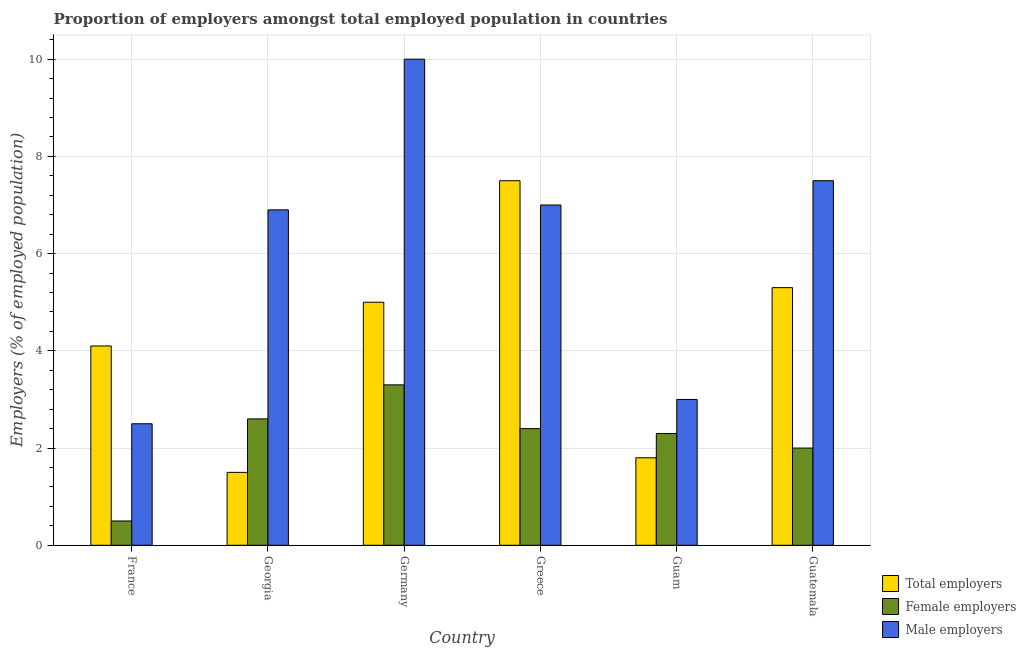How many groups of bars are there?
Provide a succinct answer. 6. How many bars are there on the 3rd tick from the left?
Offer a terse response. 3. How many bars are there on the 5th tick from the right?
Offer a terse response. 3. What is the label of the 6th group of bars from the left?
Your response must be concise. Guatemala. In how many cases, is the number of bars for a given country not equal to the number of legend labels?
Offer a very short reply. 0. Across all countries, what is the maximum percentage of total employers?
Offer a terse response. 7.5. In which country was the percentage of total employers maximum?
Keep it short and to the point. Greece. What is the total percentage of female employers in the graph?
Give a very brief answer. 13.1. What is the difference between the percentage of female employers in Guam and that in Guatemala?
Offer a terse response. 0.3. What is the difference between the percentage of male employers in Germany and the percentage of female employers in Greece?
Make the answer very short. 7.6. What is the average percentage of male employers per country?
Keep it short and to the point. 6.15. What is the difference between the percentage of male employers and percentage of total employers in France?
Ensure brevity in your answer.  -1.6. In how many countries, is the percentage of female employers greater than 2.4 %?
Ensure brevity in your answer.  3. What is the ratio of the percentage of total employers in Greece to that in Guam?
Your answer should be compact. 4.17. Is the difference between the percentage of total employers in Georgia and Greece greater than the difference between the percentage of female employers in Georgia and Greece?
Give a very brief answer. No. What is the difference between the highest and the second highest percentage of male employers?
Offer a very short reply. 2.5. What is the difference between the highest and the lowest percentage of female employers?
Make the answer very short. 2.8. What does the 1st bar from the left in France represents?
Your response must be concise. Total employers. What does the 3rd bar from the right in Georgia represents?
Provide a succinct answer. Total employers. Is it the case that in every country, the sum of the percentage of total employers and percentage of female employers is greater than the percentage of male employers?
Your answer should be compact. No. How many bars are there?
Provide a short and direct response. 18. Are all the bars in the graph horizontal?
Offer a very short reply. No. Are the values on the major ticks of Y-axis written in scientific E-notation?
Provide a succinct answer. No. Does the graph contain grids?
Offer a very short reply. Yes. Where does the legend appear in the graph?
Offer a terse response. Bottom right. How many legend labels are there?
Offer a terse response. 3. What is the title of the graph?
Offer a terse response. Proportion of employers amongst total employed population in countries. What is the label or title of the X-axis?
Your answer should be compact. Country. What is the label or title of the Y-axis?
Ensure brevity in your answer.  Employers (% of employed population). What is the Employers (% of employed population) of Total employers in France?
Offer a terse response. 4.1. What is the Employers (% of employed population) of Female employers in Georgia?
Your answer should be compact. 2.6. What is the Employers (% of employed population) of Male employers in Georgia?
Provide a short and direct response. 6.9. What is the Employers (% of employed population) in Total employers in Germany?
Provide a short and direct response. 5. What is the Employers (% of employed population) in Female employers in Germany?
Ensure brevity in your answer.  3.3. What is the Employers (% of employed population) in Female employers in Greece?
Your response must be concise. 2.4. What is the Employers (% of employed population) in Total employers in Guam?
Ensure brevity in your answer.  1.8. What is the Employers (% of employed population) of Female employers in Guam?
Ensure brevity in your answer.  2.3. What is the Employers (% of employed population) in Male employers in Guam?
Your answer should be very brief. 3. What is the Employers (% of employed population) in Total employers in Guatemala?
Ensure brevity in your answer.  5.3. What is the Employers (% of employed population) of Female employers in Guatemala?
Your response must be concise. 2. Across all countries, what is the maximum Employers (% of employed population) of Total employers?
Your answer should be compact. 7.5. Across all countries, what is the maximum Employers (% of employed population) in Female employers?
Give a very brief answer. 3.3. Across all countries, what is the minimum Employers (% of employed population) of Total employers?
Offer a very short reply. 1.5. Across all countries, what is the minimum Employers (% of employed population) in Male employers?
Offer a terse response. 2.5. What is the total Employers (% of employed population) in Total employers in the graph?
Ensure brevity in your answer.  25.2. What is the total Employers (% of employed population) of Female employers in the graph?
Your answer should be compact. 13.1. What is the total Employers (% of employed population) of Male employers in the graph?
Provide a succinct answer. 36.9. What is the difference between the Employers (% of employed population) in Total employers in France and that in Georgia?
Keep it short and to the point. 2.6. What is the difference between the Employers (% of employed population) of Female employers in France and that in Georgia?
Offer a terse response. -2.1. What is the difference between the Employers (% of employed population) of Male employers in France and that in Germany?
Provide a succinct answer. -7.5. What is the difference between the Employers (% of employed population) of Total employers in France and that in Greece?
Your answer should be compact. -3.4. What is the difference between the Employers (% of employed population) of Male employers in France and that in Greece?
Give a very brief answer. -4.5. What is the difference between the Employers (% of employed population) in Female employers in France and that in Guam?
Your response must be concise. -1.8. What is the difference between the Employers (% of employed population) in Male employers in France and that in Guatemala?
Provide a short and direct response. -5. What is the difference between the Employers (% of employed population) in Total employers in Georgia and that in Guam?
Provide a succinct answer. -0.3. What is the difference between the Employers (% of employed population) of Female employers in Georgia and that in Guam?
Ensure brevity in your answer.  0.3. What is the difference between the Employers (% of employed population) of Male employers in Georgia and that in Guam?
Offer a very short reply. 3.9. What is the difference between the Employers (% of employed population) of Total employers in Georgia and that in Guatemala?
Offer a terse response. -3.8. What is the difference between the Employers (% of employed population) in Female employers in Georgia and that in Guatemala?
Provide a succinct answer. 0.6. What is the difference between the Employers (% of employed population) in Total employers in Germany and that in Greece?
Ensure brevity in your answer.  -2.5. What is the difference between the Employers (% of employed population) of Female employers in Germany and that in Greece?
Offer a very short reply. 0.9. What is the difference between the Employers (% of employed population) in Male employers in Germany and that in Greece?
Give a very brief answer. 3. What is the difference between the Employers (% of employed population) in Total employers in Germany and that in Guam?
Ensure brevity in your answer.  3.2. What is the difference between the Employers (% of employed population) of Male employers in Germany and that in Guam?
Provide a succinct answer. 7. What is the difference between the Employers (% of employed population) in Total employers in Germany and that in Guatemala?
Provide a succinct answer. -0.3. What is the difference between the Employers (% of employed population) in Female employers in Germany and that in Guatemala?
Keep it short and to the point. 1.3. What is the difference between the Employers (% of employed population) of Male employers in Germany and that in Guatemala?
Provide a short and direct response. 2.5. What is the difference between the Employers (% of employed population) in Total employers in Greece and that in Guam?
Your response must be concise. 5.7. What is the difference between the Employers (% of employed population) of Total employers in Greece and that in Guatemala?
Ensure brevity in your answer.  2.2. What is the difference between the Employers (% of employed population) in Female employers in Greece and that in Guatemala?
Offer a very short reply. 0.4. What is the difference between the Employers (% of employed population) of Total employers in Guam and that in Guatemala?
Keep it short and to the point. -3.5. What is the difference between the Employers (% of employed population) in Total employers in France and the Employers (% of employed population) in Female employers in Georgia?
Ensure brevity in your answer.  1.5. What is the difference between the Employers (% of employed population) of Total employers in France and the Employers (% of employed population) of Male employers in Georgia?
Give a very brief answer. -2.8. What is the difference between the Employers (% of employed population) of Female employers in France and the Employers (% of employed population) of Male employers in Georgia?
Provide a succinct answer. -6.4. What is the difference between the Employers (% of employed population) in Total employers in France and the Employers (% of employed population) in Female employers in Germany?
Keep it short and to the point. 0.8. What is the difference between the Employers (% of employed population) of Total employers in France and the Employers (% of employed population) of Male employers in Germany?
Your answer should be compact. -5.9. What is the difference between the Employers (% of employed population) of Total employers in France and the Employers (% of employed population) of Female employers in Greece?
Your response must be concise. 1.7. What is the difference between the Employers (% of employed population) of Total employers in France and the Employers (% of employed population) of Male employers in Greece?
Offer a terse response. -2.9. What is the difference between the Employers (% of employed population) of Total employers in France and the Employers (% of employed population) of Female employers in Guam?
Keep it short and to the point. 1.8. What is the difference between the Employers (% of employed population) in Total employers in France and the Employers (% of employed population) in Female employers in Guatemala?
Ensure brevity in your answer.  2.1. What is the difference between the Employers (% of employed population) in Total employers in France and the Employers (% of employed population) in Male employers in Guatemala?
Make the answer very short. -3.4. What is the difference between the Employers (% of employed population) of Total employers in Georgia and the Employers (% of employed population) of Male employers in Germany?
Make the answer very short. -8.5. What is the difference between the Employers (% of employed population) in Total employers in Georgia and the Employers (% of employed population) in Female employers in Greece?
Keep it short and to the point. -0.9. What is the difference between the Employers (% of employed population) of Total employers in Georgia and the Employers (% of employed population) of Male employers in Greece?
Your answer should be compact. -5.5. What is the difference between the Employers (% of employed population) of Total employers in Georgia and the Employers (% of employed population) of Male employers in Guam?
Your answer should be very brief. -1.5. What is the difference between the Employers (% of employed population) in Total employers in Georgia and the Employers (% of employed population) in Female employers in Guatemala?
Give a very brief answer. -0.5. What is the difference between the Employers (% of employed population) of Total employers in Georgia and the Employers (% of employed population) of Male employers in Guatemala?
Offer a very short reply. -6. What is the difference between the Employers (% of employed population) in Total employers in Germany and the Employers (% of employed population) in Female employers in Greece?
Your answer should be compact. 2.6. What is the difference between the Employers (% of employed population) in Female employers in Germany and the Employers (% of employed population) in Male employers in Greece?
Provide a short and direct response. -3.7. What is the difference between the Employers (% of employed population) in Total employers in Germany and the Employers (% of employed population) in Female employers in Guatemala?
Ensure brevity in your answer.  3. What is the difference between the Employers (% of employed population) of Total employers in Greece and the Employers (% of employed population) of Male employers in Guam?
Offer a very short reply. 4.5. What is the difference between the Employers (% of employed population) in Total employers in Greece and the Employers (% of employed population) in Female employers in Guatemala?
Provide a short and direct response. 5.5. What is the difference between the Employers (% of employed population) of Total employers in Guam and the Employers (% of employed population) of Female employers in Guatemala?
Offer a very short reply. -0.2. What is the difference between the Employers (% of employed population) in Female employers in Guam and the Employers (% of employed population) in Male employers in Guatemala?
Offer a very short reply. -5.2. What is the average Employers (% of employed population) of Female employers per country?
Provide a succinct answer. 2.18. What is the average Employers (% of employed population) in Male employers per country?
Provide a succinct answer. 6.15. What is the difference between the Employers (% of employed population) in Total employers and Employers (% of employed population) in Female employers in France?
Give a very brief answer. 3.6. What is the difference between the Employers (% of employed population) of Female employers and Employers (% of employed population) of Male employers in Georgia?
Provide a succinct answer. -4.3. What is the difference between the Employers (% of employed population) in Female employers and Employers (% of employed population) in Male employers in Germany?
Provide a short and direct response. -6.7. What is the difference between the Employers (% of employed population) of Female employers and Employers (% of employed population) of Male employers in Greece?
Your response must be concise. -4.6. What is the difference between the Employers (% of employed population) of Total employers and Employers (% of employed population) of Female employers in Guam?
Keep it short and to the point. -0.5. What is the difference between the Employers (% of employed population) in Total employers and Employers (% of employed population) in Male employers in Guam?
Your answer should be compact. -1.2. What is the difference between the Employers (% of employed population) in Female employers and Employers (% of employed population) in Male employers in Guam?
Make the answer very short. -0.7. What is the difference between the Employers (% of employed population) of Total employers and Employers (% of employed population) of Female employers in Guatemala?
Keep it short and to the point. 3.3. What is the difference between the Employers (% of employed population) of Total employers and Employers (% of employed population) of Male employers in Guatemala?
Your answer should be very brief. -2.2. What is the ratio of the Employers (% of employed population) in Total employers in France to that in Georgia?
Provide a succinct answer. 2.73. What is the ratio of the Employers (% of employed population) in Female employers in France to that in Georgia?
Ensure brevity in your answer.  0.19. What is the ratio of the Employers (% of employed population) of Male employers in France to that in Georgia?
Offer a terse response. 0.36. What is the ratio of the Employers (% of employed population) in Total employers in France to that in Germany?
Give a very brief answer. 0.82. What is the ratio of the Employers (% of employed population) of Female employers in France to that in Germany?
Provide a succinct answer. 0.15. What is the ratio of the Employers (% of employed population) of Male employers in France to that in Germany?
Make the answer very short. 0.25. What is the ratio of the Employers (% of employed population) in Total employers in France to that in Greece?
Offer a terse response. 0.55. What is the ratio of the Employers (% of employed population) of Female employers in France to that in Greece?
Your answer should be compact. 0.21. What is the ratio of the Employers (% of employed population) of Male employers in France to that in Greece?
Keep it short and to the point. 0.36. What is the ratio of the Employers (% of employed population) in Total employers in France to that in Guam?
Ensure brevity in your answer.  2.28. What is the ratio of the Employers (% of employed population) in Female employers in France to that in Guam?
Keep it short and to the point. 0.22. What is the ratio of the Employers (% of employed population) in Total employers in France to that in Guatemala?
Keep it short and to the point. 0.77. What is the ratio of the Employers (% of employed population) in Female employers in France to that in Guatemala?
Provide a short and direct response. 0.25. What is the ratio of the Employers (% of employed population) of Male employers in France to that in Guatemala?
Give a very brief answer. 0.33. What is the ratio of the Employers (% of employed population) in Total employers in Georgia to that in Germany?
Your answer should be compact. 0.3. What is the ratio of the Employers (% of employed population) of Female employers in Georgia to that in Germany?
Keep it short and to the point. 0.79. What is the ratio of the Employers (% of employed population) in Male employers in Georgia to that in Germany?
Provide a succinct answer. 0.69. What is the ratio of the Employers (% of employed population) in Total employers in Georgia to that in Greece?
Keep it short and to the point. 0.2. What is the ratio of the Employers (% of employed population) of Female employers in Georgia to that in Greece?
Offer a terse response. 1.08. What is the ratio of the Employers (% of employed population) of Male employers in Georgia to that in Greece?
Your response must be concise. 0.99. What is the ratio of the Employers (% of employed population) in Total employers in Georgia to that in Guam?
Make the answer very short. 0.83. What is the ratio of the Employers (% of employed population) in Female employers in Georgia to that in Guam?
Offer a terse response. 1.13. What is the ratio of the Employers (% of employed population) in Total employers in Georgia to that in Guatemala?
Provide a succinct answer. 0.28. What is the ratio of the Employers (% of employed population) in Female employers in Georgia to that in Guatemala?
Keep it short and to the point. 1.3. What is the ratio of the Employers (% of employed population) in Female employers in Germany to that in Greece?
Ensure brevity in your answer.  1.38. What is the ratio of the Employers (% of employed population) in Male employers in Germany to that in Greece?
Keep it short and to the point. 1.43. What is the ratio of the Employers (% of employed population) in Total employers in Germany to that in Guam?
Ensure brevity in your answer.  2.78. What is the ratio of the Employers (% of employed population) of Female employers in Germany to that in Guam?
Ensure brevity in your answer.  1.43. What is the ratio of the Employers (% of employed population) of Total employers in Germany to that in Guatemala?
Provide a succinct answer. 0.94. What is the ratio of the Employers (% of employed population) of Female employers in Germany to that in Guatemala?
Your answer should be very brief. 1.65. What is the ratio of the Employers (% of employed population) in Male employers in Germany to that in Guatemala?
Provide a short and direct response. 1.33. What is the ratio of the Employers (% of employed population) of Total employers in Greece to that in Guam?
Provide a succinct answer. 4.17. What is the ratio of the Employers (% of employed population) of Female employers in Greece to that in Guam?
Keep it short and to the point. 1.04. What is the ratio of the Employers (% of employed population) of Male employers in Greece to that in Guam?
Ensure brevity in your answer.  2.33. What is the ratio of the Employers (% of employed population) in Total employers in Greece to that in Guatemala?
Provide a short and direct response. 1.42. What is the ratio of the Employers (% of employed population) in Total employers in Guam to that in Guatemala?
Ensure brevity in your answer.  0.34. What is the ratio of the Employers (% of employed population) of Female employers in Guam to that in Guatemala?
Offer a very short reply. 1.15. What is the ratio of the Employers (% of employed population) of Male employers in Guam to that in Guatemala?
Provide a short and direct response. 0.4. What is the difference between the highest and the second highest Employers (% of employed population) in Total employers?
Make the answer very short. 2.2. What is the difference between the highest and the second highest Employers (% of employed population) of Male employers?
Provide a short and direct response. 2.5. 